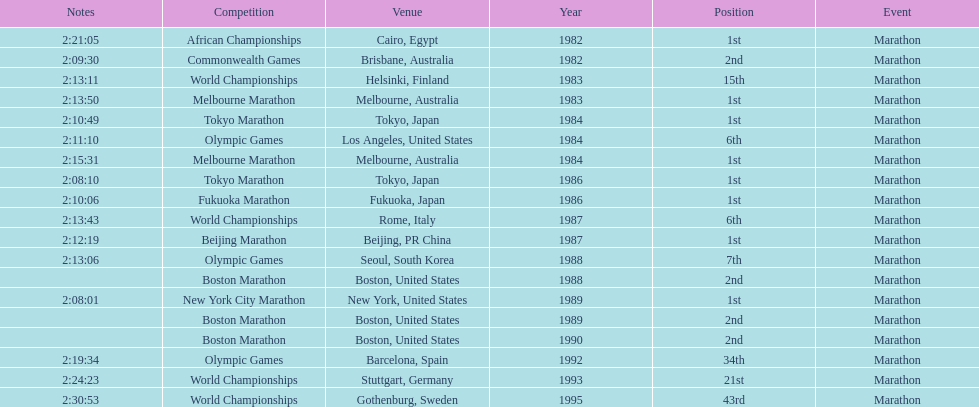Which competition is listed the most in this chart? World Championships. 